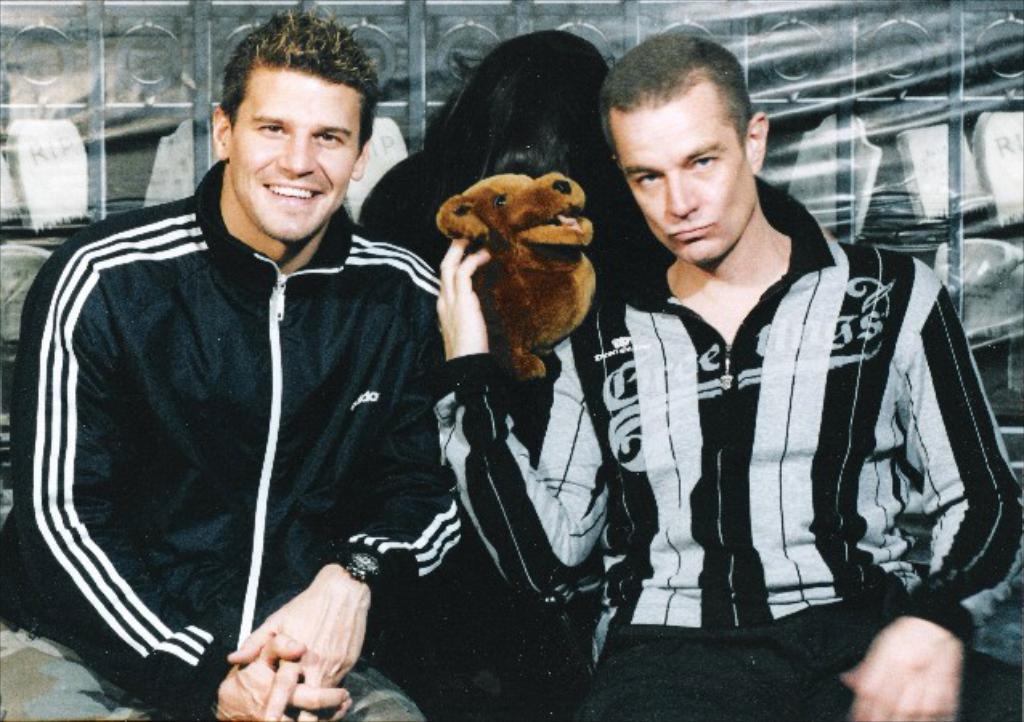Please provide a concise description of this image. In this picture we can see so two persons are sitting and holding a dog. 